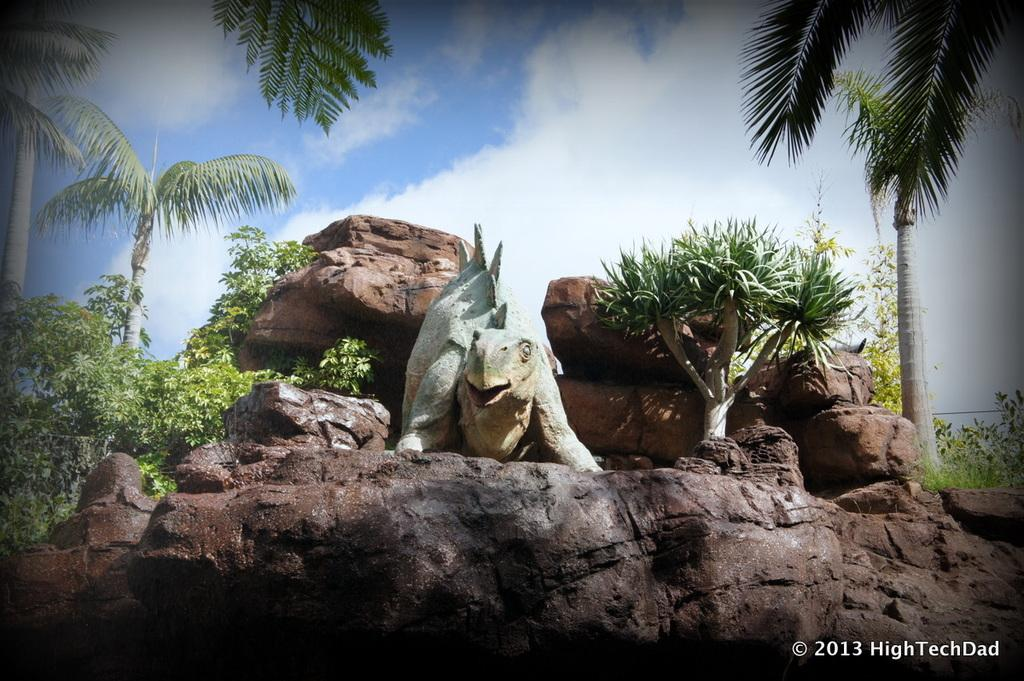What type of living creature can be seen in the image? There is an animal in the image. What other natural elements are present in the image? There are plants, a rock, and trees in the image. What can be seen in the background of the image? The sky is visible in the background of the image, and there are clouds in the sky. What type of lunch is being served in the image? There is no lunch present in the image; it features an animal, plants, a rock, trees, and a sky with clouds. 